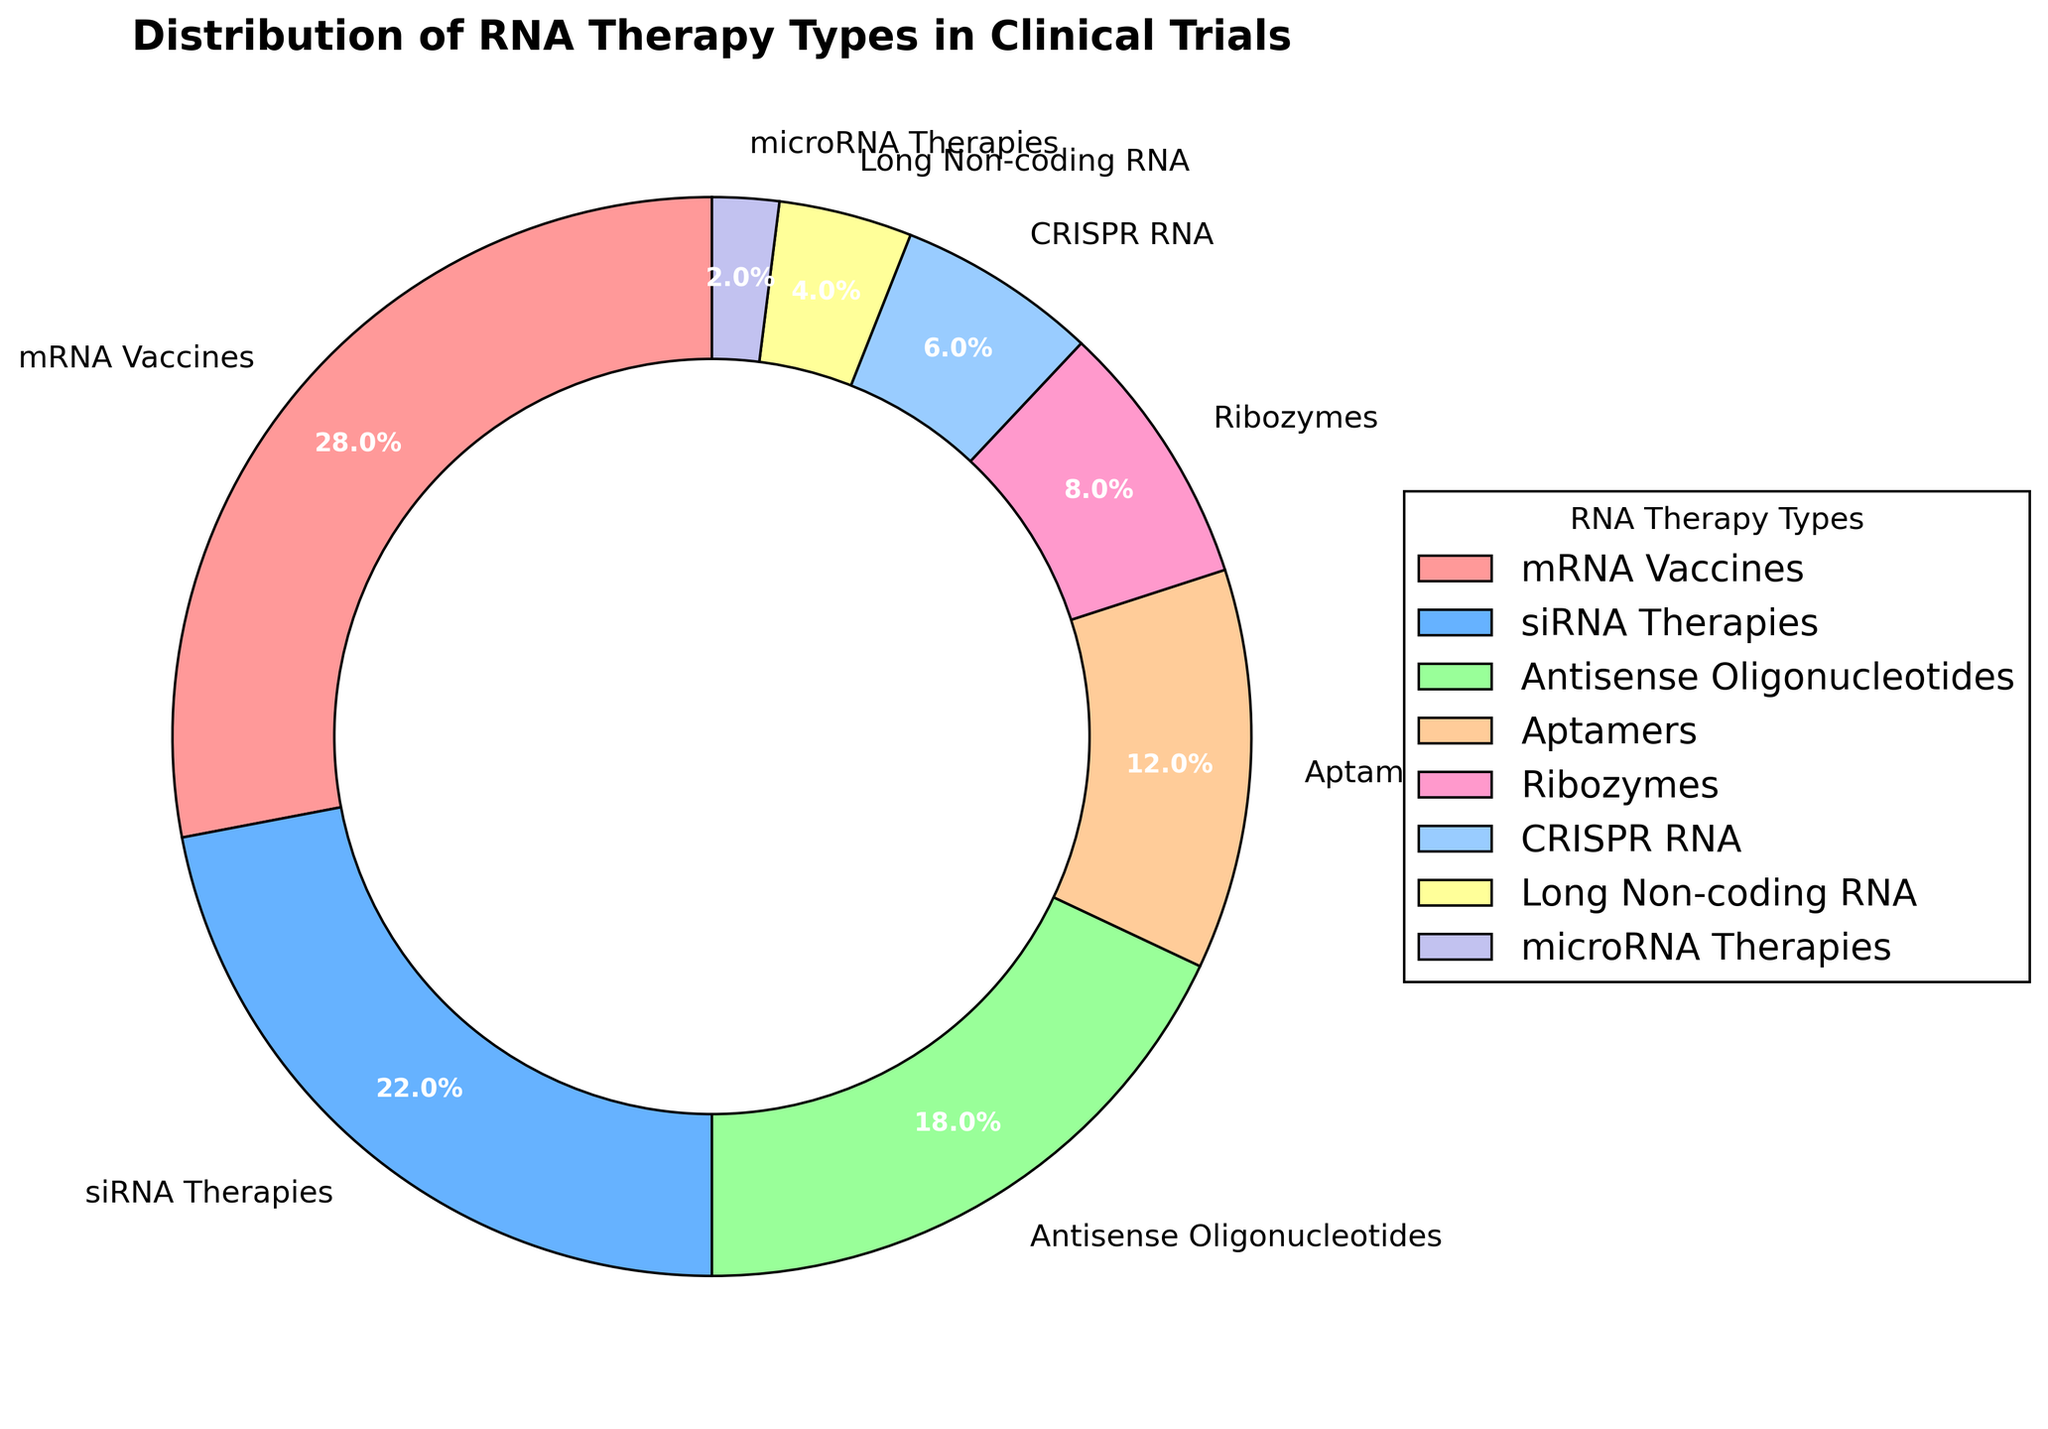Which RNA therapy type has the highest percentage? The segment for mRNA Vaccines appears to be the largest in the pie chart, indicating it has the highest percentage among the RNA therapy types.
Answer: mRNA Vaccines What is the combined percentage of siRNA Therapies and Antisense Oligonucleotides? To find the combined percentage, add the percentages of siRNA Therapies (22%) and Antisense Oligonucleotides (18%). 22 + 18 = 40
Answer: 40 Which RNA therapy type has a lower percentage, Aptamers or Ribozymes? Comparing the slices for Aptamers (12%) and Ribozymes (8%), Ribozymes have a lower percentage than Aptamers.
Answer: Ribozymes What is the total percentage of RNA therapy types that are below 10% each? Sum the percentages of Ribozymes (8%), CRISPR RNA (6%), Long Non-coding RNA (4%), and microRNA Therapies (2%). 8 + 6 + 4 + 2 = 20
Answer: 20 Among the RNA therapy types, which one has the smallest percentage? The smallest slice in the pie chart belongs to microRNA Therapies, indicating it has the smallest percentage.
Answer: microRNA Therapies How much greater is the percentage of mRNA Vaccines compared to CRISPR RNA? Subtract the percentage of CRISPR RNA (6%) from the percentage of mRNA Vaccines (28%). 28 - 6 = 22
Answer: 22 What is the percentage difference between siRNA Therapies and Aptamers? Subtract the percentage of Aptamers (12%) from the percentage of siRNA Therapies (22%). 22 - 12 = 10
Answer: 10 Which color represents Antisense Oligonucleotides in the pie chart? The slice in the chart for Antisense Oligonucleotides is colored with a light green shade.
Answer: light green (99FF99) 